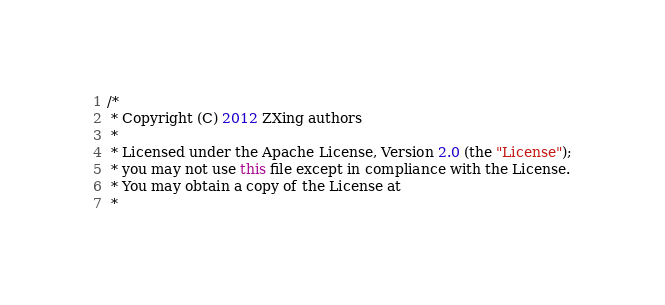Convert code to text. <code><loc_0><loc_0><loc_500><loc_500><_Java_>/*
 * Copyright (C) 2012 ZXing authors
 *
 * Licensed under the Apache License, Version 2.0 (the "License");
 * you may not use this file except in compliance with the License.
 * You may obtain a copy of the License at
 *</code> 